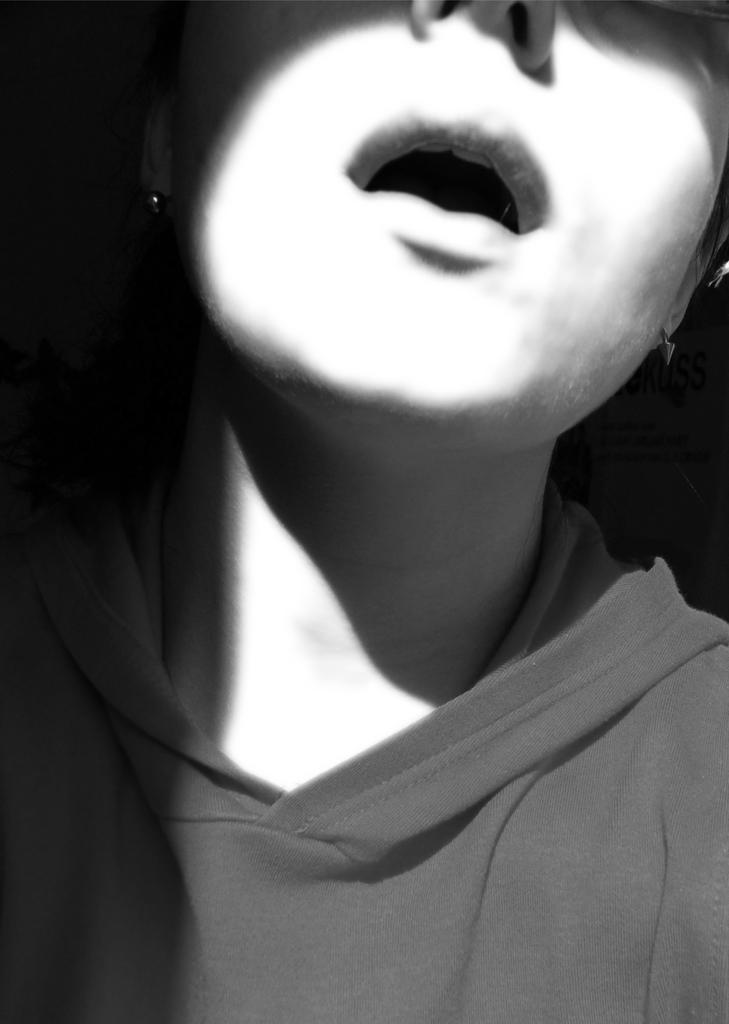What type of picture is in the image? The image contains a black and white picture of a person. What is the person in the picture wearing? The person in the picture is wearing a dress. What color is the background of the black and white picture? The background of the black and white picture is black in color. What time does the person in the picture join the meeting? The image does not provide any information about a meeting or a specific time, as it only shows a black and white picture of a person wearing a dress. 